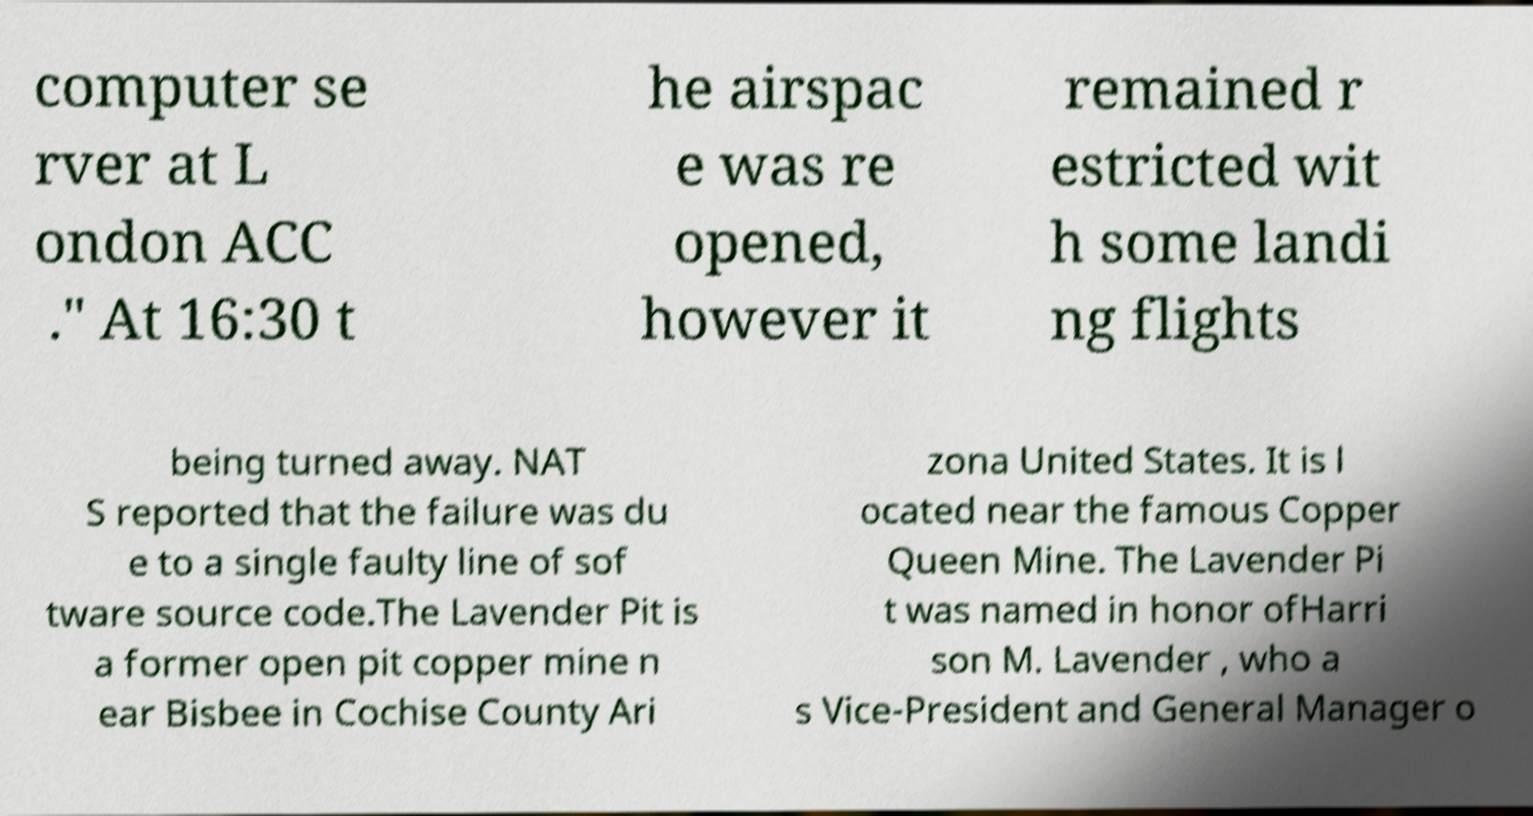Could you extract and type out the text from this image? computer se rver at L ondon ACC ." At 16:30 t he airspac e was re opened, however it remained r estricted wit h some landi ng flights being turned away. NAT S reported that the failure was du e to a single faulty line of sof tware source code.The Lavender Pit is a former open pit copper mine n ear Bisbee in Cochise County Ari zona United States. It is l ocated near the famous Copper Queen Mine. The Lavender Pi t was named in honor ofHarri son M. Lavender , who a s Vice-President and General Manager o 